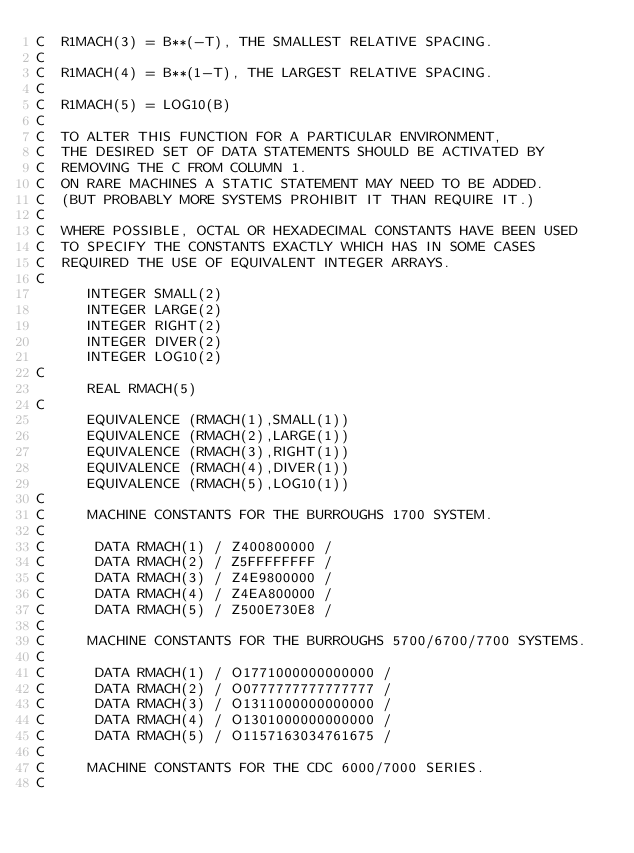Convert code to text. <code><loc_0><loc_0><loc_500><loc_500><_FORTRAN_>C  R1MACH(3) = B**(-T), THE SMALLEST RELATIVE SPACING.
C
C  R1MACH(4) = B**(1-T), THE LARGEST RELATIVE SPACING.
C
C  R1MACH(5) = LOG10(B)
C
C  TO ALTER THIS FUNCTION FOR A PARTICULAR ENVIRONMENT,
C  THE DESIRED SET OF DATA STATEMENTS SHOULD BE ACTIVATED BY
C  REMOVING THE C FROM COLUMN 1.
C  ON RARE MACHINES A STATIC STATEMENT MAY NEED TO BE ADDED.
C  (BUT PROBABLY MORE SYSTEMS PROHIBIT IT THAN REQUIRE IT.)
C
C  WHERE POSSIBLE, OCTAL OR HEXADECIMAL CONSTANTS HAVE BEEN USED
C  TO SPECIFY THE CONSTANTS EXACTLY WHICH HAS IN SOME CASES
C  REQUIRED THE USE OF EQUIVALENT INTEGER ARRAYS.
C
      INTEGER SMALL(2)
      INTEGER LARGE(2)
      INTEGER RIGHT(2)
      INTEGER DIVER(2)
      INTEGER LOG10(2)
C
      REAL RMACH(5)
C
      EQUIVALENCE (RMACH(1),SMALL(1))
      EQUIVALENCE (RMACH(2),LARGE(1))
      EQUIVALENCE (RMACH(3),RIGHT(1))
      EQUIVALENCE (RMACH(4),DIVER(1))
      EQUIVALENCE (RMACH(5),LOG10(1))
C
C     MACHINE CONSTANTS FOR THE BURROUGHS 1700 SYSTEM.
C
C      DATA RMACH(1) / Z400800000 /
C      DATA RMACH(2) / Z5FFFFFFFF /
C      DATA RMACH(3) / Z4E9800000 /
C      DATA RMACH(4) / Z4EA800000 /
C      DATA RMACH(5) / Z500E730E8 /
C
C     MACHINE CONSTANTS FOR THE BURROUGHS 5700/6700/7700 SYSTEMS.
C
C      DATA RMACH(1) / O1771000000000000 /
C      DATA RMACH(2) / O0777777777777777 /
C      DATA RMACH(3) / O1311000000000000 /
C      DATA RMACH(4) / O1301000000000000 /
C      DATA RMACH(5) / O1157163034761675 /
C
C     MACHINE CONSTANTS FOR THE CDC 6000/7000 SERIES.
C</code> 